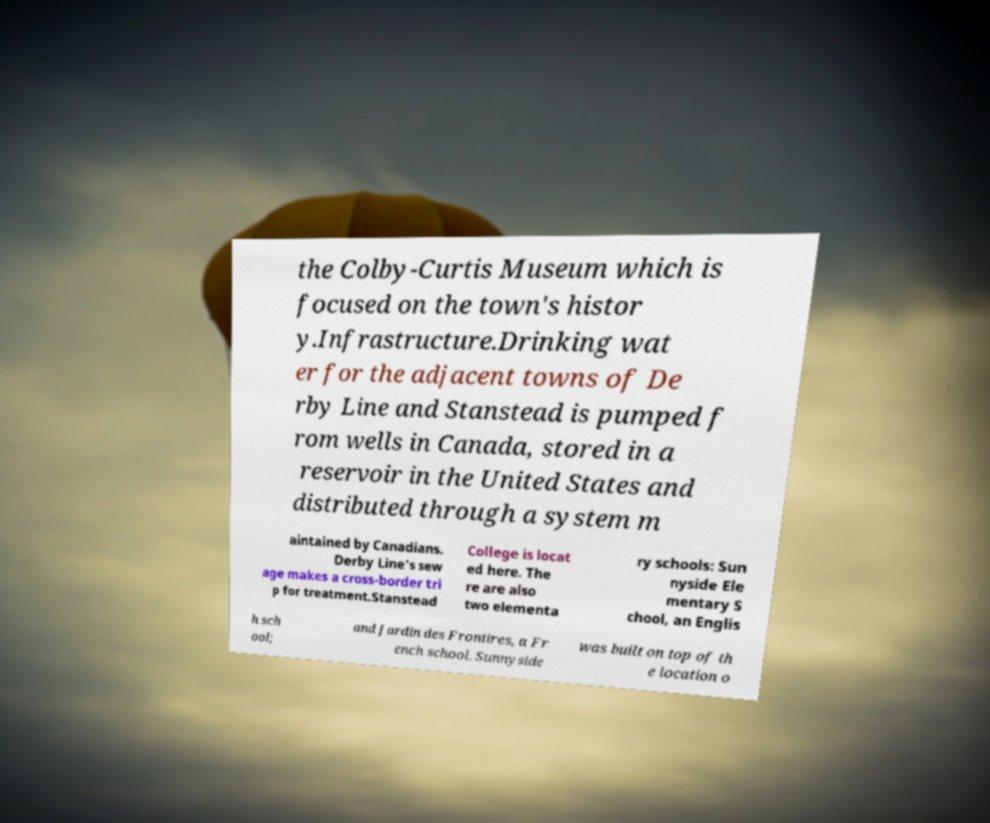There's text embedded in this image that I need extracted. Can you transcribe it verbatim? the Colby-Curtis Museum which is focused on the town's histor y.Infrastructure.Drinking wat er for the adjacent towns of De rby Line and Stanstead is pumped f rom wells in Canada, stored in a reservoir in the United States and distributed through a system m aintained by Canadians. Derby Line's sew age makes a cross-border tri p for treatment.Stanstead College is locat ed here. The re are also two elementa ry schools: Sun nyside Ele mentary S chool, an Englis h sch ool; and Jardin des Frontires, a Fr ench school. Sunnyside was built on top of th e location o 